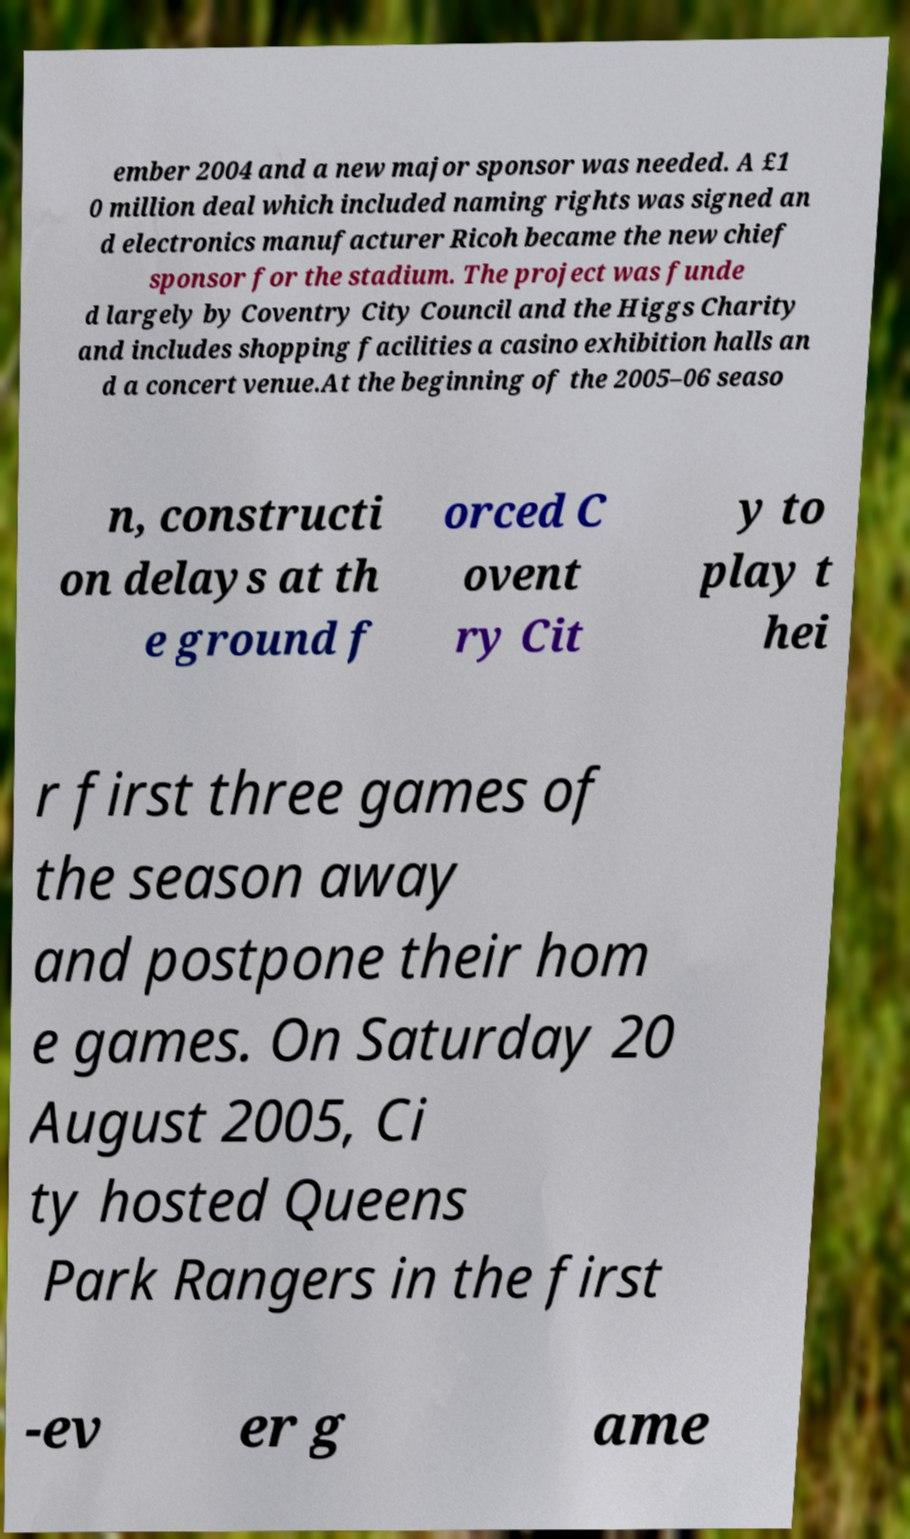Please read and relay the text visible in this image. What does it say? ember 2004 and a new major sponsor was needed. A £1 0 million deal which included naming rights was signed an d electronics manufacturer Ricoh became the new chief sponsor for the stadium. The project was funde d largely by Coventry City Council and the Higgs Charity and includes shopping facilities a casino exhibition halls an d a concert venue.At the beginning of the 2005–06 seaso n, constructi on delays at th e ground f orced C ovent ry Cit y to play t hei r first three games of the season away and postpone their hom e games. On Saturday 20 August 2005, Ci ty hosted Queens Park Rangers in the first -ev er g ame 